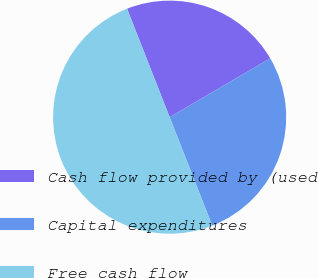Convert chart to OTSL. <chart><loc_0><loc_0><loc_500><loc_500><pie_chart><fcel>Cash flow provided by (used<fcel>Capital expenditures<fcel>Free cash flow<nl><fcel>22.53%<fcel>27.47%<fcel>50.0%<nl></chart> 